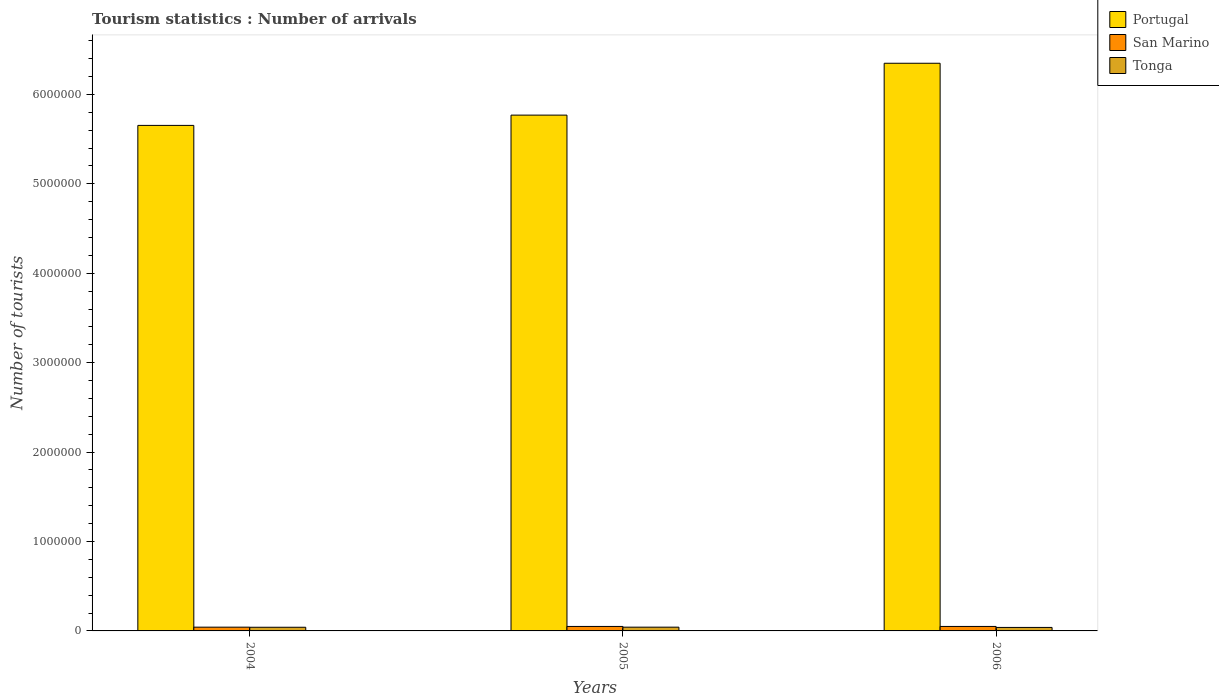How many different coloured bars are there?
Ensure brevity in your answer.  3. Are the number of bars per tick equal to the number of legend labels?
Your answer should be compact. Yes. Are the number of bars on each tick of the X-axis equal?
Your answer should be very brief. Yes. How many bars are there on the 1st tick from the right?
Make the answer very short. 3. What is the label of the 2nd group of bars from the left?
Keep it short and to the point. 2005. In how many cases, is the number of bars for a given year not equal to the number of legend labels?
Provide a succinct answer. 0. What is the number of tourist arrivals in Portugal in 2005?
Provide a short and direct response. 5.77e+06. Across all years, what is the maximum number of tourist arrivals in Portugal?
Make the answer very short. 6.35e+06. Across all years, what is the minimum number of tourist arrivals in San Marino?
Keep it short and to the point. 4.20e+04. In which year was the number of tourist arrivals in San Marino maximum?
Offer a terse response. 2005. What is the total number of tourist arrivals in Tonga in the graph?
Your response must be concise. 1.22e+05. What is the difference between the number of tourist arrivals in Tonga in 2005 and that in 2006?
Ensure brevity in your answer.  3000. What is the difference between the number of tourist arrivals in San Marino in 2005 and the number of tourist arrivals in Portugal in 2004?
Your answer should be compact. -5.60e+06. What is the average number of tourist arrivals in San Marino per year?
Give a very brief answer. 4.73e+04. In the year 2006, what is the difference between the number of tourist arrivals in San Marino and number of tourist arrivals in Portugal?
Keep it short and to the point. -6.30e+06. What is the difference between the highest and the lowest number of tourist arrivals in San Marino?
Your response must be concise. 8000. What does the 2nd bar from the left in 2005 represents?
Give a very brief answer. San Marino. What does the 1st bar from the right in 2006 represents?
Provide a succinct answer. Tonga. How many bars are there?
Give a very brief answer. 9. Are all the bars in the graph horizontal?
Keep it short and to the point. No. Are the values on the major ticks of Y-axis written in scientific E-notation?
Your response must be concise. No. How are the legend labels stacked?
Your answer should be very brief. Vertical. What is the title of the graph?
Provide a succinct answer. Tourism statistics : Number of arrivals. What is the label or title of the Y-axis?
Your response must be concise. Number of tourists. What is the Number of tourists in Portugal in 2004?
Give a very brief answer. 5.65e+06. What is the Number of tourists in San Marino in 2004?
Make the answer very short. 4.20e+04. What is the Number of tourists in Tonga in 2004?
Make the answer very short. 4.10e+04. What is the Number of tourists in Portugal in 2005?
Offer a terse response. 5.77e+06. What is the Number of tourists of Tonga in 2005?
Keep it short and to the point. 4.20e+04. What is the Number of tourists of Portugal in 2006?
Provide a succinct answer. 6.35e+06. What is the Number of tourists of Tonga in 2006?
Offer a very short reply. 3.90e+04. Across all years, what is the maximum Number of tourists in Portugal?
Give a very brief answer. 6.35e+06. Across all years, what is the maximum Number of tourists of Tonga?
Ensure brevity in your answer.  4.20e+04. Across all years, what is the minimum Number of tourists in Portugal?
Your response must be concise. 5.65e+06. Across all years, what is the minimum Number of tourists in San Marino?
Offer a very short reply. 4.20e+04. Across all years, what is the minimum Number of tourists in Tonga?
Your answer should be compact. 3.90e+04. What is the total Number of tourists in Portugal in the graph?
Ensure brevity in your answer.  1.78e+07. What is the total Number of tourists of San Marino in the graph?
Your answer should be compact. 1.42e+05. What is the total Number of tourists in Tonga in the graph?
Provide a succinct answer. 1.22e+05. What is the difference between the Number of tourists in Portugal in 2004 and that in 2005?
Offer a very short reply. -1.15e+05. What is the difference between the Number of tourists in San Marino in 2004 and that in 2005?
Give a very brief answer. -8000. What is the difference between the Number of tourists of Tonga in 2004 and that in 2005?
Offer a terse response. -1000. What is the difference between the Number of tourists in Portugal in 2004 and that in 2006?
Offer a terse response. -6.95e+05. What is the difference between the Number of tourists in San Marino in 2004 and that in 2006?
Offer a terse response. -8000. What is the difference between the Number of tourists of Tonga in 2004 and that in 2006?
Your answer should be compact. 2000. What is the difference between the Number of tourists in Portugal in 2005 and that in 2006?
Your answer should be compact. -5.80e+05. What is the difference between the Number of tourists of Tonga in 2005 and that in 2006?
Offer a terse response. 3000. What is the difference between the Number of tourists of Portugal in 2004 and the Number of tourists of San Marino in 2005?
Offer a terse response. 5.60e+06. What is the difference between the Number of tourists of Portugal in 2004 and the Number of tourists of Tonga in 2005?
Your answer should be compact. 5.61e+06. What is the difference between the Number of tourists of San Marino in 2004 and the Number of tourists of Tonga in 2005?
Provide a short and direct response. 0. What is the difference between the Number of tourists in Portugal in 2004 and the Number of tourists in San Marino in 2006?
Ensure brevity in your answer.  5.60e+06. What is the difference between the Number of tourists of Portugal in 2004 and the Number of tourists of Tonga in 2006?
Your answer should be very brief. 5.62e+06. What is the difference between the Number of tourists in San Marino in 2004 and the Number of tourists in Tonga in 2006?
Your answer should be compact. 3000. What is the difference between the Number of tourists of Portugal in 2005 and the Number of tourists of San Marino in 2006?
Keep it short and to the point. 5.72e+06. What is the difference between the Number of tourists of Portugal in 2005 and the Number of tourists of Tonga in 2006?
Provide a short and direct response. 5.73e+06. What is the difference between the Number of tourists in San Marino in 2005 and the Number of tourists in Tonga in 2006?
Provide a short and direct response. 1.10e+04. What is the average Number of tourists of Portugal per year?
Your answer should be very brief. 5.92e+06. What is the average Number of tourists in San Marino per year?
Ensure brevity in your answer.  4.73e+04. What is the average Number of tourists of Tonga per year?
Give a very brief answer. 4.07e+04. In the year 2004, what is the difference between the Number of tourists of Portugal and Number of tourists of San Marino?
Provide a succinct answer. 5.61e+06. In the year 2004, what is the difference between the Number of tourists in Portugal and Number of tourists in Tonga?
Provide a short and direct response. 5.61e+06. In the year 2004, what is the difference between the Number of tourists of San Marino and Number of tourists of Tonga?
Offer a terse response. 1000. In the year 2005, what is the difference between the Number of tourists of Portugal and Number of tourists of San Marino?
Your answer should be compact. 5.72e+06. In the year 2005, what is the difference between the Number of tourists in Portugal and Number of tourists in Tonga?
Offer a very short reply. 5.73e+06. In the year 2005, what is the difference between the Number of tourists in San Marino and Number of tourists in Tonga?
Your answer should be compact. 8000. In the year 2006, what is the difference between the Number of tourists of Portugal and Number of tourists of San Marino?
Give a very brief answer. 6.30e+06. In the year 2006, what is the difference between the Number of tourists in Portugal and Number of tourists in Tonga?
Your response must be concise. 6.31e+06. In the year 2006, what is the difference between the Number of tourists in San Marino and Number of tourists in Tonga?
Your answer should be very brief. 1.10e+04. What is the ratio of the Number of tourists of Portugal in 2004 to that in 2005?
Offer a terse response. 0.98. What is the ratio of the Number of tourists in San Marino in 2004 to that in 2005?
Give a very brief answer. 0.84. What is the ratio of the Number of tourists of Tonga in 2004 to that in 2005?
Make the answer very short. 0.98. What is the ratio of the Number of tourists of Portugal in 2004 to that in 2006?
Your answer should be compact. 0.89. What is the ratio of the Number of tourists of San Marino in 2004 to that in 2006?
Give a very brief answer. 0.84. What is the ratio of the Number of tourists in Tonga in 2004 to that in 2006?
Your answer should be compact. 1.05. What is the ratio of the Number of tourists in Portugal in 2005 to that in 2006?
Your answer should be very brief. 0.91. What is the difference between the highest and the second highest Number of tourists of Portugal?
Provide a succinct answer. 5.80e+05. What is the difference between the highest and the lowest Number of tourists of Portugal?
Provide a short and direct response. 6.95e+05. What is the difference between the highest and the lowest Number of tourists in San Marino?
Give a very brief answer. 8000. What is the difference between the highest and the lowest Number of tourists of Tonga?
Your response must be concise. 3000. 